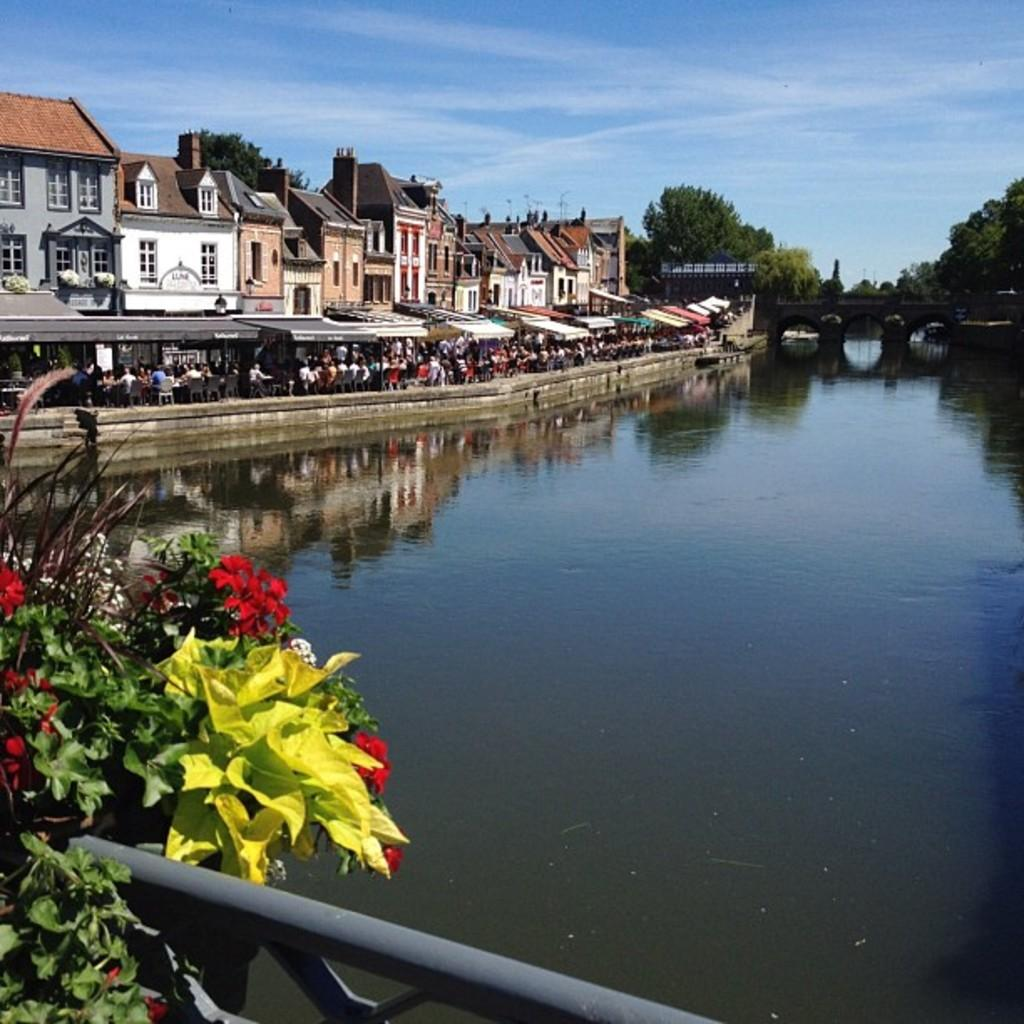What type of natural feature is on the left side of the image? There is a lake on the left side of the image. What type of man-made structures are on the right side of the image? There are buildings on the right side of the image. What are the people in the image doing? People are walking on a road in the image. What is visible in the sky in the image? The sky is visible in the image. What type of watch is the creator wearing in the image? There is no creator or watch present in the image. What is the condition of the road in the image? The provided facts do not mention the condition of the road, so it cannot be determined from the image. 